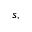Convert formula to latex. <formula><loc_0><loc_0><loc_500><loc_500>s ,</formula> 